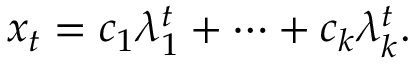<formula> <loc_0><loc_0><loc_500><loc_500>x _ { t } = c _ { 1 } \lambda _ { 1 } ^ { t } + \cdots + c _ { k } \lambda _ { k } ^ { t } .</formula> 